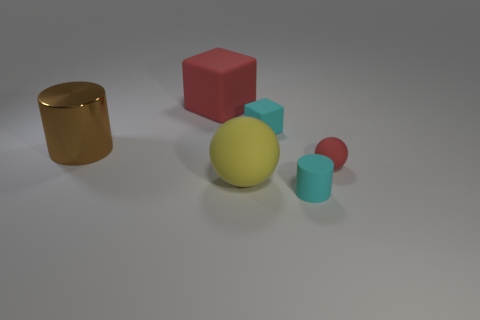Add 2 tiny yellow matte cubes. How many objects exist? 8 Subtract all yellow spheres. How many spheres are left? 1 Add 3 red matte things. How many red matte things are left? 5 Add 1 large cubes. How many large cubes exist? 2 Subtract 0 brown cubes. How many objects are left? 6 Subtract all spheres. How many objects are left? 4 Subtract 1 cubes. How many cubes are left? 1 Subtract all green cylinders. Subtract all green blocks. How many cylinders are left? 2 Subtract all red blocks. How many brown cylinders are left? 1 Subtract all tiny green spheres. Subtract all tiny red matte things. How many objects are left? 5 